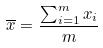Convert formula to latex. <formula><loc_0><loc_0><loc_500><loc_500>\overline { x } = \frac { \sum _ { i = 1 } ^ { m } x _ { i } } { m }</formula> 